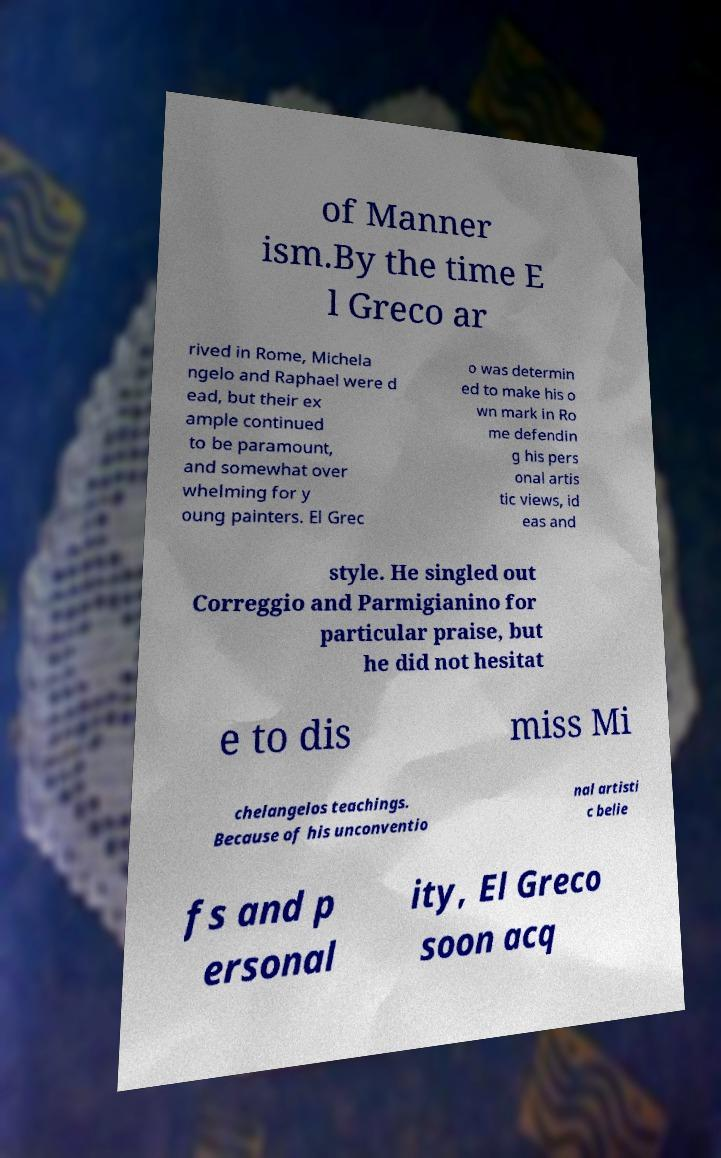For documentation purposes, I need the text within this image transcribed. Could you provide that? of Manner ism.By the time E l Greco ar rived in Rome, Michela ngelo and Raphael were d ead, but their ex ample continued to be paramount, and somewhat over whelming for y oung painters. El Grec o was determin ed to make his o wn mark in Ro me defendin g his pers onal artis tic views, id eas and style. He singled out Correggio and Parmigianino for particular praise, but he did not hesitat e to dis miss Mi chelangelos teachings. Because of his unconventio nal artisti c belie fs and p ersonal ity, El Greco soon acq 